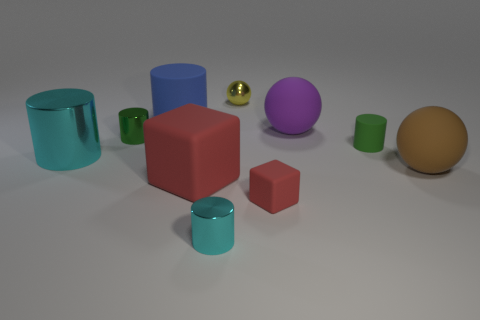Subtract all yellow cubes. Subtract all green balls. How many cubes are left? 2 Subtract all red cylinders. How many gray balls are left? 0 Add 5 cyans. How many big blues exist? 0 Subtract all spheres. Subtract all big blue cubes. How many objects are left? 7 Add 7 yellow things. How many yellow things are left? 8 Add 4 blue matte objects. How many blue matte objects exist? 5 Subtract all purple balls. How many balls are left? 2 Subtract all yellow balls. How many balls are left? 2 Subtract 0 blue balls. How many objects are left? 10 How many cyan cylinders must be subtracted to get 1 cyan cylinders? 1 